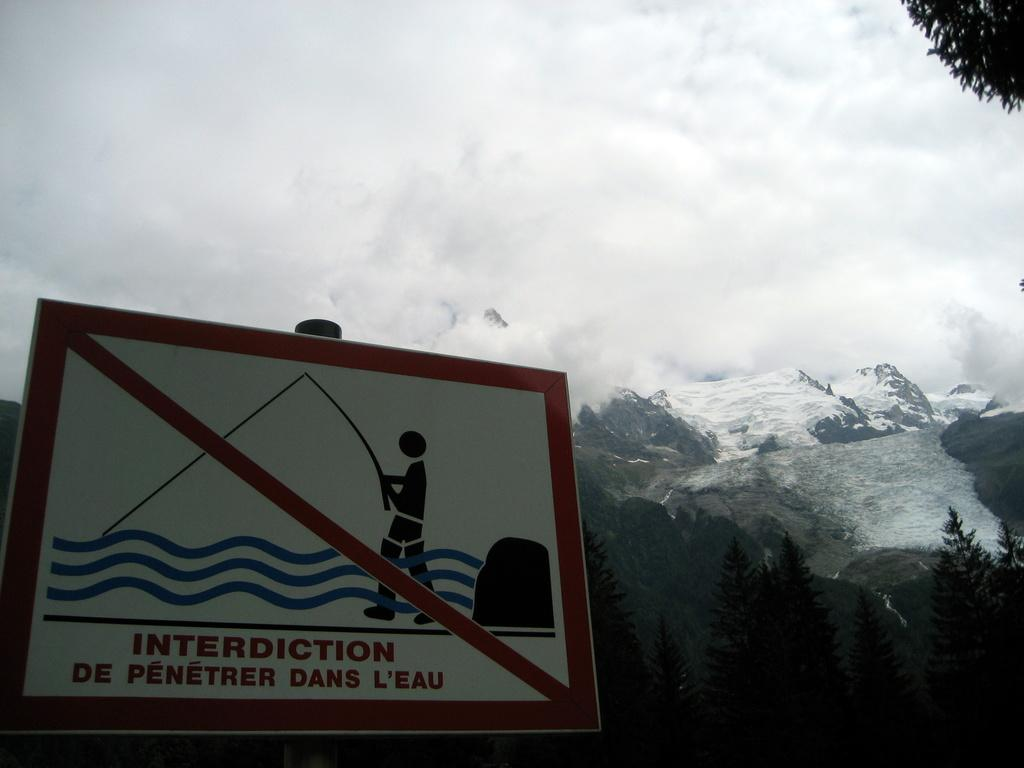<image>
Share a concise interpretation of the image provided. A sign with a man fishing with a red line through it and in a foreign language the sign says no fishing. 